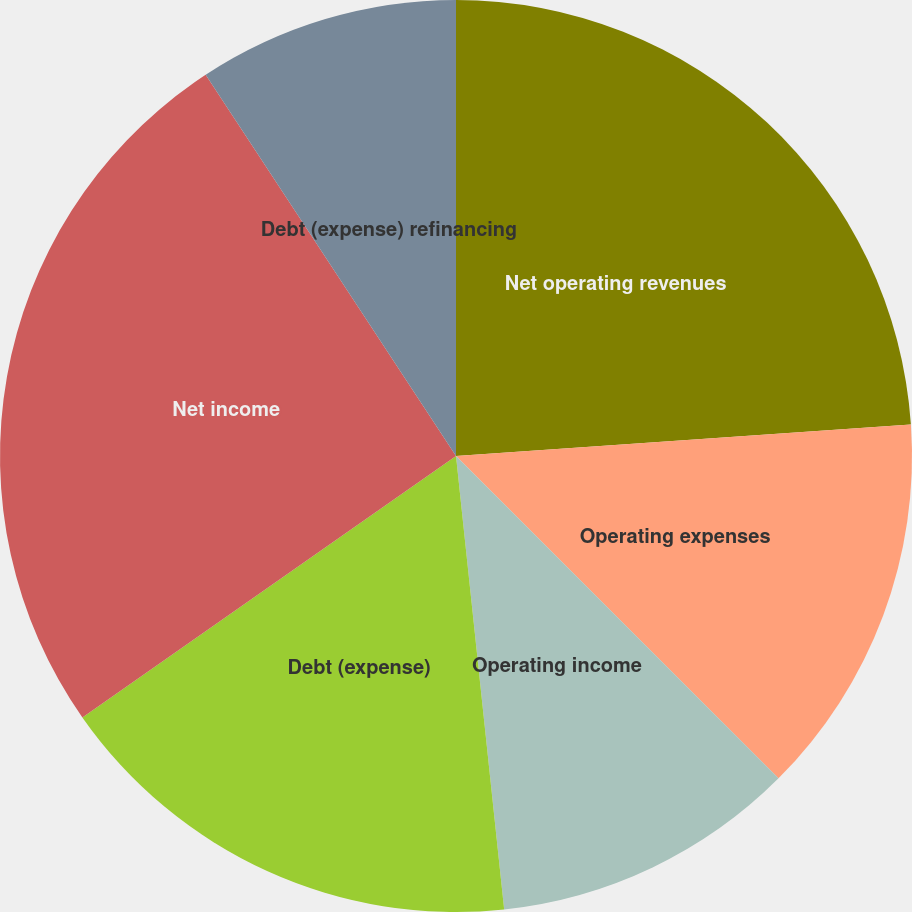Convert chart. <chart><loc_0><loc_0><loc_500><loc_500><pie_chart><fcel>Net operating revenues<fcel>Operating expenses<fcel>Operating income<fcel>Debt (expense)<fcel>Net income<fcel>Debt (expense) refinancing<nl><fcel>23.9%<fcel>13.6%<fcel>10.82%<fcel>16.97%<fcel>25.47%<fcel>9.25%<nl></chart> 